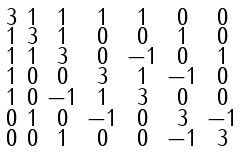<formula> <loc_0><loc_0><loc_500><loc_500>\begin{smallmatrix} 3 & 1 & 1 & 1 & 1 & 0 & 0 \\ 1 & 3 & 1 & 0 & 0 & 1 & 0 \\ 1 & 1 & 3 & 0 & - 1 & 0 & 1 \\ 1 & 0 & 0 & 3 & 1 & - 1 & 0 \\ 1 & 0 & - 1 & 1 & 3 & 0 & 0 \\ 0 & 1 & 0 & - 1 & 0 & 3 & - 1 \\ 0 & 0 & 1 & 0 & 0 & - 1 & 3 \end{smallmatrix}</formula> 